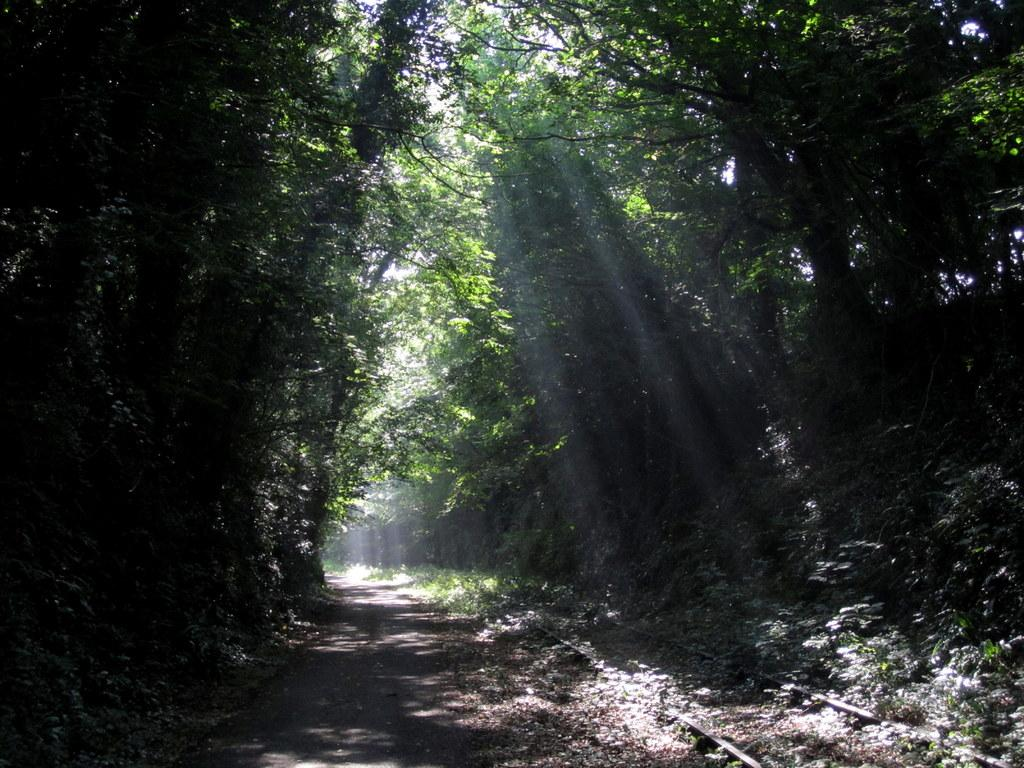What is the main feature of the image? There is a road in the image. What can be seen near the road? There are tracks near the road. What type of natural environment is visible in the image? There are many trees in the image. What is visible in the background of the image? The sky is visible in the background of the image. What type of attraction can be seen near the road in the image? There is no specific attraction mentioned or visible in the image; it primarily features a road, tracks, trees, and the sky. 